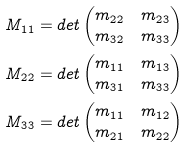Convert formula to latex. <formula><loc_0><loc_0><loc_500><loc_500>M _ { 1 1 } & = d e t \begin{pmatrix} m _ { 2 2 } & m _ { 2 3 } \\ m _ { 3 2 } & m _ { 3 3 } \end{pmatrix} \\ M _ { 2 2 } & = d e t \begin{pmatrix} m _ { 1 1 } & m _ { 1 3 } \\ m _ { 3 1 } & m _ { 3 3 } \end{pmatrix} \\ M _ { 3 3 } & = d e t \begin{pmatrix} m _ { 1 1 } & m _ { 1 2 } \\ m _ { 2 1 } & m _ { 2 2 } \end{pmatrix}</formula> 